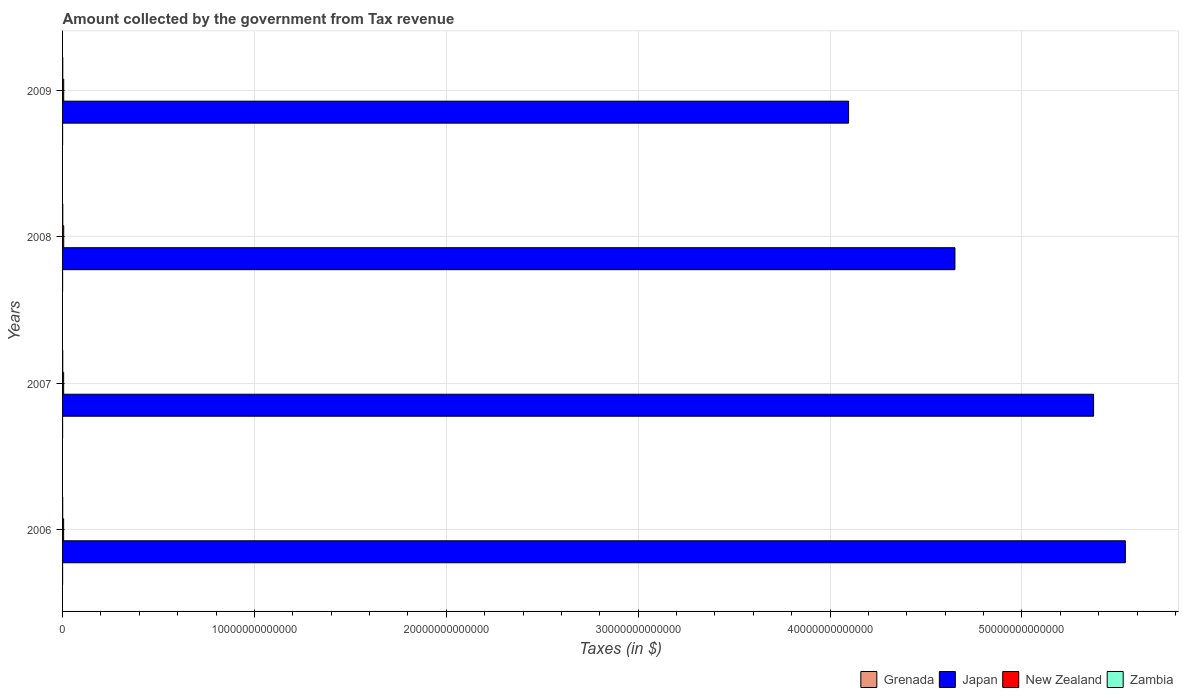How many different coloured bars are there?
Provide a succinct answer. 4. How many bars are there on the 3rd tick from the top?
Make the answer very short. 4. How many bars are there on the 2nd tick from the bottom?
Keep it short and to the point. 4. What is the amount collected by the government from tax revenue in New Zealand in 2006?
Your answer should be compact. 5.50e+1. Across all years, what is the maximum amount collected by the government from tax revenue in Grenada?
Keep it short and to the point. 4.34e+08. Across all years, what is the minimum amount collected by the government from tax revenue in Japan?
Provide a succinct answer. 4.10e+13. In which year was the amount collected by the government from tax revenue in New Zealand minimum?
Give a very brief answer. 2006. What is the total amount collected by the government from tax revenue in New Zealand in the graph?
Your answer should be very brief. 2.31e+11. What is the difference between the amount collected by the government from tax revenue in Japan in 2006 and that in 2009?
Keep it short and to the point. 1.44e+13. What is the difference between the amount collected by the government from tax revenue in Zambia in 2006 and the amount collected by the government from tax revenue in Japan in 2008?
Provide a short and direct response. -4.65e+13. What is the average amount collected by the government from tax revenue in Zambia per year?
Make the answer very short. 8.33e+09. In the year 2008, what is the difference between the amount collected by the government from tax revenue in New Zealand and amount collected by the government from tax revenue in Grenada?
Ensure brevity in your answer.  5.93e+1. In how many years, is the amount collected by the government from tax revenue in Grenada greater than 56000000000000 $?
Your answer should be very brief. 0. What is the ratio of the amount collected by the government from tax revenue in Japan in 2007 to that in 2009?
Your answer should be compact. 1.31. Is the difference between the amount collected by the government from tax revenue in New Zealand in 2006 and 2008 greater than the difference between the amount collected by the government from tax revenue in Grenada in 2006 and 2008?
Keep it short and to the point. No. What is the difference between the highest and the second highest amount collected by the government from tax revenue in New Zealand?
Your answer should be very brief. 6.41e+07. What is the difference between the highest and the lowest amount collected by the government from tax revenue in Grenada?
Your answer should be very brief. 7.38e+07. Is it the case that in every year, the sum of the amount collected by the government from tax revenue in Japan and amount collected by the government from tax revenue in New Zealand is greater than the sum of amount collected by the government from tax revenue in Zambia and amount collected by the government from tax revenue in Grenada?
Make the answer very short. Yes. What does the 1st bar from the top in 2007 represents?
Provide a succinct answer. Zambia. What does the 1st bar from the bottom in 2009 represents?
Provide a succinct answer. Grenada. Are all the bars in the graph horizontal?
Provide a short and direct response. Yes. What is the difference between two consecutive major ticks on the X-axis?
Ensure brevity in your answer.  1.00e+13. Does the graph contain any zero values?
Ensure brevity in your answer.  No. Does the graph contain grids?
Your response must be concise. Yes. Where does the legend appear in the graph?
Your response must be concise. Bottom right. How are the legend labels stacked?
Provide a short and direct response. Horizontal. What is the title of the graph?
Provide a succinct answer. Amount collected by the government from Tax revenue. What is the label or title of the X-axis?
Your answer should be very brief. Taxes (in $). What is the label or title of the Y-axis?
Give a very brief answer. Years. What is the Taxes (in $) of Grenada in 2006?
Keep it short and to the point. 3.60e+08. What is the Taxes (in $) of Japan in 2006?
Provide a succinct answer. 5.54e+13. What is the Taxes (in $) of New Zealand in 2006?
Your answer should be very brief. 5.50e+1. What is the Taxes (in $) of Zambia in 2006?
Ensure brevity in your answer.  6.30e+09. What is the Taxes (in $) of Grenada in 2007?
Your response must be concise. 4.03e+08. What is the Taxes (in $) of Japan in 2007?
Keep it short and to the point. 5.37e+13. What is the Taxes (in $) in New Zealand in 2007?
Offer a terse response. 5.62e+1. What is the Taxes (in $) of Zambia in 2007?
Your answer should be compact. 7.80e+09. What is the Taxes (in $) of Grenada in 2008?
Offer a terse response. 4.34e+08. What is the Taxes (in $) in Japan in 2008?
Your answer should be very brief. 4.65e+13. What is the Taxes (in $) in New Zealand in 2008?
Your answer should be very brief. 5.97e+1. What is the Taxes (in $) of Zambia in 2008?
Provide a succinct answer. 9.54e+09. What is the Taxes (in $) in Grenada in 2009?
Your response must be concise. 3.80e+08. What is the Taxes (in $) of Japan in 2009?
Your answer should be very brief. 4.10e+13. What is the Taxes (in $) in New Zealand in 2009?
Your response must be concise. 5.96e+1. What is the Taxes (in $) of Zambia in 2009?
Make the answer very short. 9.67e+09. Across all years, what is the maximum Taxes (in $) in Grenada?
Ensure brevity in your answer.  4.34e+08. Across all years, what is the maximum Taxes (in $) in Japan?
Your answer should be compact. 5.54e+13. Across all years, what is the maximum Taxes (in $) in New Zealand?
Offer a terse response. 5.97e+1. Across all years, what is the maximum Taxes (in $) of Zambia?
Make the answer very short. 9.67e+09. Across all years, what is the minimum Taxes (in $) in Grenada?
Keep it short and to the point. 3.60e+08. Across all years, what is the minimum Taxes (in $) of Japan?
Provide a short and direct response. 4.10e+13. Across all years, what is the minimum Taxes (in $) in New Zealand?
Your answer should be very brief. 5.50e+1. Across all years, what is the minimum Taxes (in $) of Zambia?
Your answer should be compact. 6.30e+09. What is the total Taxes (in $) in Grenada in the graph?
Give a very brief answer. 1.58e+09. What is the total Taxes (in $) in Japan in the graph?
Ensure brevity in your answer.  1.97e+14. What is the total Taxes (in $) in New Zealand in the graph?
Offer a terse response. 2.31e+11. What is the total Taxes (in $) in Zambia in the graph?
Offer a terse response. 3.33e+1. What is the difference between the Taxes (in $) of Grenada in 2006 and that in 2007?
Provide a short and direct response. -4.28e+07. What is the difference between the Taxes (in $) of Japan in 2006 and that in 2007?
Provide a succinct answer. 1.66e+12. What is the difference between the Taxes (in $) of New Zealand in 2006 and that in 2007?
Your response must be concise. -1.19e+09. What is the difference between the Taxes (in $) in Zambia in 2006 and that in 2007?
Offer a very short reply. -1.50e+09. What is the difference between the Taxes (in $) of Grenada in 2006 and that in 2008?
Keep it short and to the point. -7.38e+07. What is the difference between the Taxes (in $) in Japan in 2006 and that in 2008?
Provide a succinct answer. 8.88e+12. What is the difference between the Taxes (in $) of New Zealand in 2006 and that in 2008?
Your answer should be compact. -4.69e+09. What is the difference between the Taxes (in $) of Zambia in 2006 and that in 2008?
Provide a short and direct response. -3.24e+09. What is the difference between the Taxes (in $) in Grenada in 2006 and that in 2009?
Make the answer very short. -1.99e+07. What is the difference between the Taxes (in $) in Japan in 2006 and that in 2009?
Offer a terse response. 1.44e+13. What is the difference between the Taxes (in $) in New Zealand in 2006 and that in 2009?
Give a very brief answer. -4.63e+09. What is the difference between the Taxes (in $) of Zambia in 2006 and that in 2009?
Provide a short and direct response. -3.37e+09. What is the difference between the Taxes (in $) in Grenada in 2007 and that in 2008?
Offer a terse response. -3.10e+07. What is the difference between the Taxes (in $) in Japan in 2007 and that in 2008?
Your answer should be compact. 7.23e+12. What is the difference between the Taxes (in $) in New Zealand in 2007 and that in 2008?
Give a very brief answer. -3.50e+09. What is the difference between the Taxes (in $) of Zambia in 2007 and that in 2008?
Ensure brevity in your answer.  -1.74e+09. What is the difference between the Taxes (in $) in Grenada in 2007 and that in 2009?
Keep it short and to the point. 2.29e+07. What is the difference between the Taxes (in $) of Japan in 2007 and that in 2009?
Provide a succinct answer. 1.28e+13. What is the difference between the Taxes (in $) of New Zealand in 2007 and that in 2009?
Provide a short and direct response. -3.44e+09. What is the difference between the Taxes (in $) in Zambia in 2007 and that in 2009?
Ensure brevity in your answer.  -1.87e+09. What is the difference between the Taxes (in $) of Grenada in 2008 and that in 2009?
Offer a terse response. 5.39e+07. What is the difference between the Taxes (in $) in Japan in 2008 and that in 2009?
Make the answer very short. 5.54e+12. What is the difference between the Taxes (in $) in New Zealand in 2008 and that in 2009?
Ensure brevity in your answer.  6.41e+07. What is the difference between the Taxes (in $) in Zambia in 2008 and that in 2009?
Your answer should be compact. -1.29e+08. What is the difference between the Taxes (in $) in Grenada in 2006 and the Taxes (in $) in Japan in 2007?
Keep it short and to the point. -5.37e+13. What is the difference between the Taxes (in $) in Grenada in 2006 and the Taxes (in $) in New Zealand in 2007?
Offer a terse response. -5.58e+1. What is the difference between the Taxes (in $) of Grenada in 2006 and the Taxes (in $) of Zambia in 2007?
Ensure brevity in your answer.  -7.44e+09. What is the difference between the Taxes (in $) of Japan in 2006 and the Taxes (in $) of New Zealand in 2007?
Your answer should be compact. 5.53e+13. What is the difference between the Taxes (in $) of Japan in 2006 and the Taxes (in $) of Zambia in 2007?
Offer a terse response. 5.54e+13. What is the difference between the Taxes (in $) in New Zealand in 2006 and the Taxes (in $) in Zambia in 2007?
Provide a short and direct response. 4.72e+1. What is the difference between the Taxes (in $) of Grenada in 2006 and the Taxes (in $) of Japan in 2008?
Give a very brief answer. -4.65e+13. What is the difference between the Taxes (in $) of Grenada in 2006 and the Taxes (in $) of New Zealand in 2008?
Offer a terse response. -5.94e+1. What is the difference between the Taxes (in $) in Grenada in 2006 and the Taxes (in $) in Zambia in 2008?
Provide a succinct answer. -9.18e+09. What is the difference between the Taxes (in $) of Japan in 2006 and the Taxes (in $) of New Zealand in 2008?
Provide a short and direct response. 5.53e+13. What is the difference between the Taxes (in $) of Japan in 2006 and the Taxes (in $) of Zambia in 2008?
Ensure brevity in your answer.  5.54e+13. What is the difference between the Taxes (in $) of New Zealand in 2006 and the Taxes (in $) of Zambia in 2008?
Your answer should be very brief. 4.55e+1. What is the difference between the Taxes (in $) of Grenada in 2006 and the Taxes (in $) of Japan in 2009?
Make the answer very short. -4.10e+13. What is the difference between the Taxes (in $) of Grenada in 2006 and the Taxes (in $) of New Zealand in 2009?
Your response must be concise. -5.93e+1. What is the difference between the Taxes (in $) of Grenada in 2006 and the Taxes (in $) of Zambia in 2009?
Offer a very short reply. -9.31e+09. What is the difference between the Taxes (in $) of Japan in 2006 and the Taxes (in $) of New Zealand in 2009?
Offer a terse response. 5.53e+13. What is the difference between the Taxes (in $) in Japan in 2006 and the Taxes (in $) in Zambia in 2009?
Your answer should be very brief. 5.54e+13. What is the difference between the Taxes (in $) of New Zealand in 2006 and the Taxes (in $) of Zambia in 2009?
Your response must be concise. 4.53e+1. What is the difference between the Taxes (in $) in Grenada in 2007 and the Taxes (in $) in Japan in 2008?
Offer a terse response. -4.65e+13. What is the difference between the Taxes (in $) of Grenada in 2007 and the Taxes (in $) of New Zealand in 2008?
Provide a short and direct response. -5.93e+1. What is the difference between the Taxes (in $) in Grenada in 2007 and the Taxes (in $) in Zambia in 2008?
Offer a very short reply. -9.14e+09. What is the difference between the Taxes (in $) in Japan in 2007 and the Taxes (in $) in New Zealand in 2008?
Offer a very short reply. 5.37e+13. What is the difference between the Taxes (in $) of Japan in 2007 and the Taxes (in $) of Zambia in 2008?
Make the answer very short. 5.37e+13. What is the difference between the Taxes (in $) of New Zealand in 2007 and the Taxes (in $) of Zambia in 2008?
Make the answer very short. 4.67e+1. What is the difference between the Taxes (in $) in Grenada in 2007 and the Taxes (in $) in Japan in 2009?
Your response must be concise. -4.10e+13. What is the difference between the Taxes (in $) of Grenada in 2007 and the Taxes (in $) of New Zealand in 2009?
Keep it short and to the point. -5.92e+1. What is the difference between the Taxes (in $) of Grenada in 2007 and the Taxes (in $) of Zambia in 2009?
Provide a short and direct response. -9.26e+09. What is the difference between the Taxes (in $) in Japan in 2007 and the Taxes (in $) in New Zealand in 2009?
Provide a succinct answer. 5.37e+13. What is the difference between the Taxes (in $) of Japan in 2007 and the Taxes (in $) of Zambia in 2009?
Give a very brief answer. 5.37e+13. What is the difference between the Taxes (in $) of New Zealand in 2007 and the Taxes (in $) of Zambia in 2009?
Your response must be concise. 4.65e+1. What is the difference between the Taxes (in $) of Grenada in 2008 and the Taxes (in $) of Japan in 2009?
Provide a short and direct response. -4.10e+13. What is the difference between the Taxes (in $) in Grenada in 2008 and the Taxes (in $) in New Zealand in 2009?
Keep it short and to the point. -5.92e+1. What is the difference between the Taxes (in $) of Grenada in 2008 and the Taxes (in $) of Zambia in 2009?
Give a very brief answer. -9.23e+09. What is the difference between the Taxes (in $) in Japan in 2008 and the Taxes (in $) in New Zealand in 2009?
Keep it short and to the point. 4.64e+13. What is the difference between the Taxes (in $) in Japan in 2008 and the Taxes (in $) in Zambia in 2009?
Provide a succinct answer. 4.65e+13. What is the difference between the Taxes (in $) in New Zealand in 2008 and the Taxes (in $) in Zambia in 2009?
Your response must be concise. 5.00e+1. What is the average Taxes (in $) in Grenada per year?
Keep it short and to the point. 3.94e+08. What is the average Taxes (in $) in Japan per year?
Your answer should be compact. 4.91e+13. What is the average Taxes (in $) of New Zealand per year?
Offer a very short reply. 5.76e+1. What is the average Taxes (in $) of Zambia per year?
Ensure brevity in your answer.  8.33e+09. In the year 2006, what is the difference between the Taxes (in $) of Grenada and Taxes (in $) of Japan?
Your answer should be compact. -5.54e+13. In the year 2006, what is the difference between the Taxes (in $) in Grenada and Taxes (in $) in New Zealand?
Your answer should be compact. -5.47e+1. In the year 2006, what is the difference between the Taxes (in $) in Grenada and Taxes (in $) in Zambia?
Keep it short and to the point. -5.94e+09. In the year 2006, what is the difference between the Taxes (in $) of Japan and Taxes (in $) of New Zealand?
Give a very brief answer. 5.53e+13. In the year 2006, what is the difference between the Taxes (in $) in Japan and Taxes (in $) in Zambia?
Offer a very short reply. 5.54e+13. In the year 2006, what is the difference between the Taxes (in $) in New Zealand and Taxes (in $) in Zambia?
Your response must be concise. 4.87e+1. In the year 2007, what is the difference between the Taxes (in $) in Grenada and Taxes (in $) in Japan?
Your answer should be very brief. -5.37e+13. In the year 2007, what is the difference between the Taxes (in $) of Grenada and Taxes (in $) of New Zealand?
Your response must be concise. -5.58e+1. In the year 2007, what is the difference between the Taxes (in $) of Grenada and Taxes (in $) of Zambia?
Keep it short and to the point. -7.40e+09. In the year 2007, what is the difference between the Taxes (in $) of Japan and Taxes (in $) of New Zealand?
Your response must be concise. 5.37e+13. In the year 2007, what is the difference between the Taxes (in $) in Japan and Taxes (in $) in Zambia?
Keep it short and to the point. 5.37e+13. In the year 2007, what is the difference between the Taxes (in $) of New Zealand and Taxes (in $) of Zambia?
Ensure brevity in your answer.  4.84e+1. In the year 2008, what is the difference between the Taxes (in $) in Grenada and Taxes (in $) in Japan?
Offer a very short reply. -4.65e+13. In the year 2008, what is the difference between the Taxes (in $) in Grenada and Taxes (in $) in New Zealand?
Give a very brief answer. -5.93e+1. In the year 2008, what is the difference between the Taxes (in $) of Grenada and Taxes (in $) of Zambia?
Give a very brief answer. -9.11e+09. In the year 2008, what is the difference between the Taxes (in $) in Japan and Taxes (in $) in New Zealand?
Offer a very short reply. 4.64e+13. In the year 2008, what is the difference between the Taxes (in $) in Japan and Taxes (in $) in Zambia?
Your answer should be very brief. 4.65e+13. In the year 2008, what is the difference between the Taxes (in $) of New Zealand and Taxes (in $) of Zambia?
Provide a succinct answer. 5.02e+1. In the year 2009, what is the difference between the Taxes (in $) in Grenada and Taxes (in $) in Japan?
Give a very brief answer. -4.10e+13. In the year 2009, what is the difference between the Taxes (in $) in Grenada and Taxes (in $) in New Zealand?
Your answer should be compact. -5.93e+1. In the year 2009, what is the difference between the Taxes (in $) in Grenada and Taxes (in $) in Zambia?
Your answer should be compact. -9.29e+09. In the year 2009, what is the difference between the Taxes (in $) in Japan and Taxes (in $) in New Zealand?
Provide a short and direct response. 4.09e+13. In the year 2009, what is the difference between the Taxes (in $) in Japan and Taxes (in $) in Zambia?
Your answer should be compact. 4.10e+13. In the year 2009, what is the difference between the Taxes (in $) in New Zealand and Taxes (in $) in Zambia?
Your response must be concise. 5.00e+1. What is the ratio of the Taxes (in $) in Grenada in 2006 to that in 2007?
Your response must be concise. 0.89. What is the ratio of the Taxes (in $) in Japan in 2006 to that in 2007?
Your response must be concise. 1.03. What is the ratio of the Taxes (in $) of New Zealand in 2006 to that in 2007?
Your answer should be compact. 0.98. What is the ratio of the Taxes (in $) of Zambia in 2006 to that in 2007?
Give a very brief answer. 0.81. What is the ratio of the Taxes (in $) of Grenada in 2006 to that in 2008?
Offer a terse response. 0.83. What is the ratio of the Taxes (in $) in Japan in 2006 to that in 2008?
Ensure brevity in your answer.  1.19. What is the ratio of the Taxes (in $) of New Zealand in 2006 to that in 2008?
Give a very brief answer. 0.92. What is the ratio of the Taxes (in $) in Zambia in 2006 to that in 2008?
Provide a succinct answer. 0.66. What is the ratio of the Taxes (in $) of Grenada in 2006 to that in 2009?
Offer a very short reply. 0.95. What is the ratio of the Taxes (in $) of Japan in 2006 to that in 2009?
Your answer should be compact. 1.35. What is the ratio of the Taxes (in $) of New Zealand in 2006 to that in 2009?
Keep it short and to the point. 0.92. What is the ratio of the Taxes (in $) of Zambia in 2006 to that in 2009?
Your response must be concise. 0.65. What is the ratio of the Taxes (in $) of Grenada in 2007 to that in 2008?
Offer a terse response. 0.93. What is the ratio of the Taxes (in $) in Japan in 2007 to that in 2008?
Provide a succinct answer. 1.16. What is the ratio of the Taxes (in $) of New Zealand in 2007 to that in 2008?
Keep it short and to the point. 0.94. What is the ratio of the Taxes (in $) in Zambia in 2007 to that in 2008?
Provide a short and direct response. 0.82. What is the ratio of the Taxes (in $) of Grenada in 2007 to that in 2009?
Your answer should be compact. 1.06. What is the ratio of the Taxes (in $) in Japan in 2007 to that in 2009?
Your answer should be compact. 1.31. What is the ratio of the Taxes (in $) of New Zealand in 2007 to that in 2009?
Your answer should be compact. 0.94. What is the ratio of the Taxes (in $) in Zambia in 2007 to that in 2009?
Provide a succinct answer. 0.81. What is the ratio of the Taxes (in $) in Grenada in 2008 to that in 2009?
Your response must be concise. 1.14. What is the ratio of the Taxes (in $) of Japan in 2008 to that in 2009?
Keep it short and to the point. 1.14. What is the ratio of the Taxes (in $) in Zambia in 2008 to that in 2009?
Offer a terse response. 0.99. What is the difference between the highest and the second highest Taxes (in $) of Grenada?
Make the answer very short. 3.10e+07. What is the difference between the highest and the second highest Taxes (in $) in Japan?
Offer a terse response. 1.66e+12. What is the difference between the highest and the second highest Taxes (in $) in New Zealand?
Your response must be concise. 6.41e+07. What is the difference between the highest and the second highest Taxes (in $) of Zambia?
Provide a succinct answer. 1.29e+08. What is the difference between the highest and the lowest Taxes (in $) in Grenada?
Your answer should be compact. 7.38e+07. What is the difference between the highest and the lowest Taxes (in $) in Japan?
Offer a terse response. 1.44e+13. What is the difference between the highest and the lowest Taxes (in $) in New Zealand?
Your answer should be very brief. 4.69e+09. What is the difference between the highest and the lowest Taxes (in $) in Zambia?
Provide a short and direct response. 3.37e+09. 